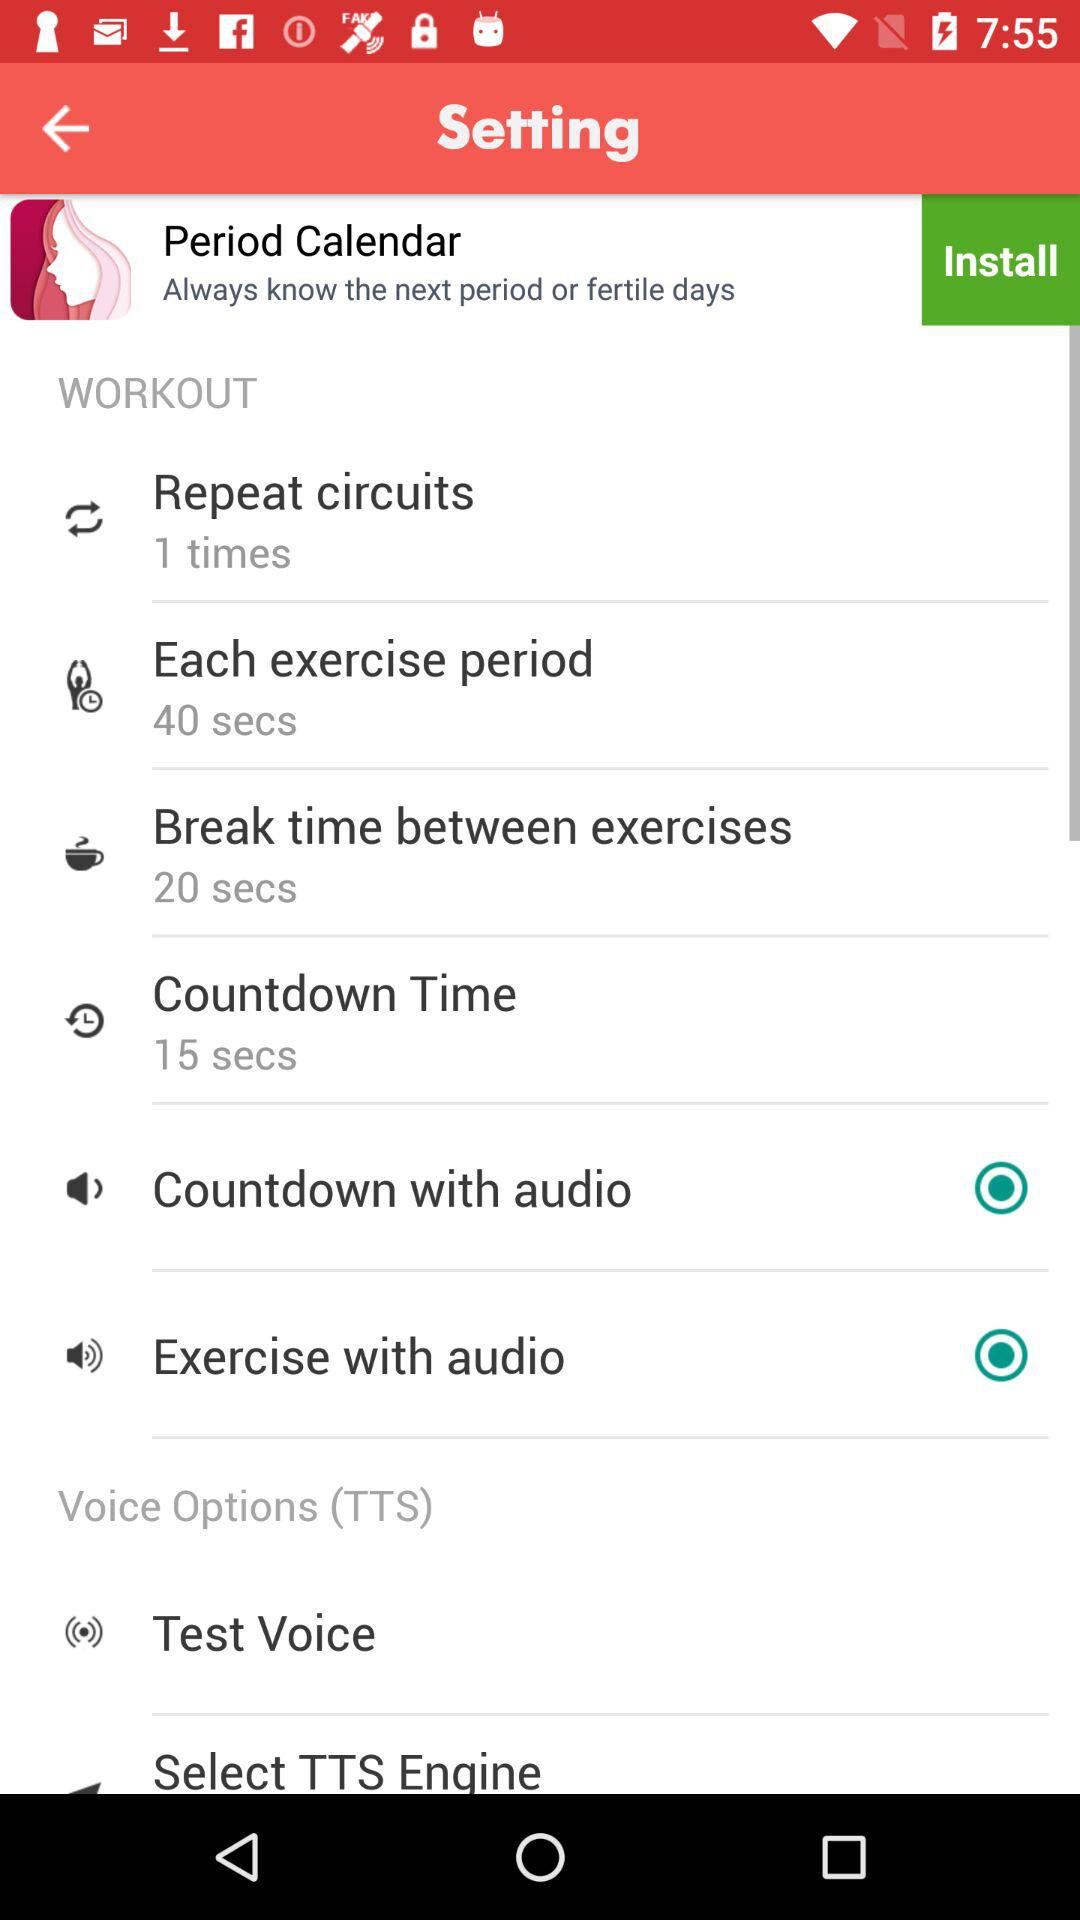What is the "Countdown Time"? The "Countdown Time" is 15 seconds. 